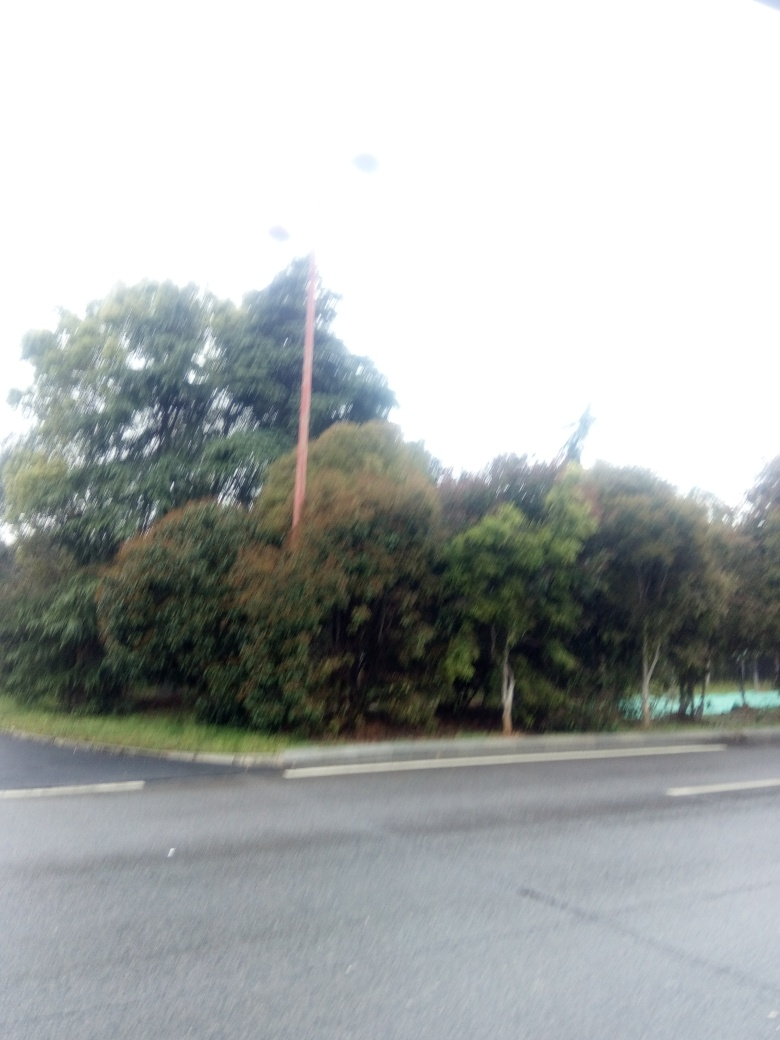What type of camera settings could prevent an image like this from being overexposed? To avoid overexposure, one should use a lower ISO setting, faster shutter speed, or a smaller aperture. Using the camera's manual mode or exposure compensation can help to achieve a balanced exposure that captures the scene more accurately. 